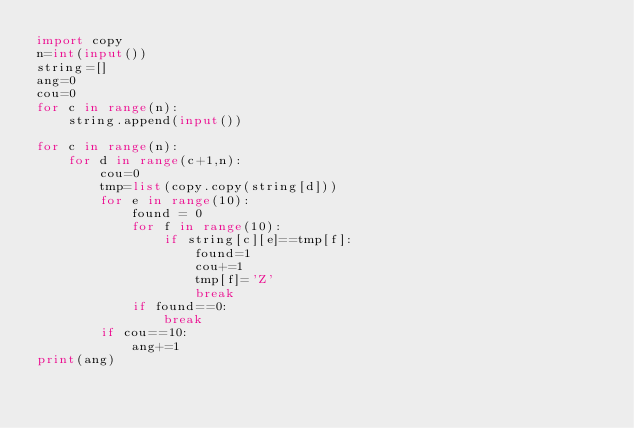<code> <loc_0><loc_0><loc_500><loc_500><_Python_>import copy
n=int(input())
string=[]
ang=0
cou=0
for c in range(n):
    string.append(input())
    
for c in range(n):
    for d in range(c+1,n):
        cou=0
        tmp=list(copy.copy(string[d]))
        for e in range(10):
            found = 0
            for f in range(10):
                if string[c][e]==tmp[f]:
                    found=1
                    cou+=1
                    tmp[f]='Z'
                    break
            if found==0:
                break
        if cou==10:
            ang+=1
print(ang)</code> 